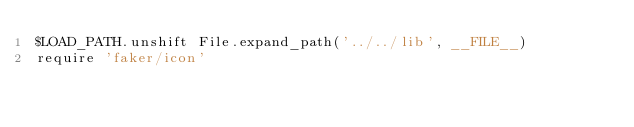<code> <loc_0><loc_0><loc_500><loc_500><_Ruby_>$LOAD_PATH.unshift File.expand_path('../../lib', __FILE__)
require 'faker/icon'
</code> 